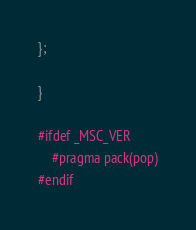<code> <loc_0><loc_0><loc_500><loc_500><_C++_>};

}

#ifdef _MSC_VER
	#pragma pack(pop)
#endif
</code> 